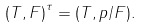<formula> <loc_0><loc_0><loc_500><loc_500>{ ( T , F ) } ^ { \tau } = ( T , p / F ) .</formula> 